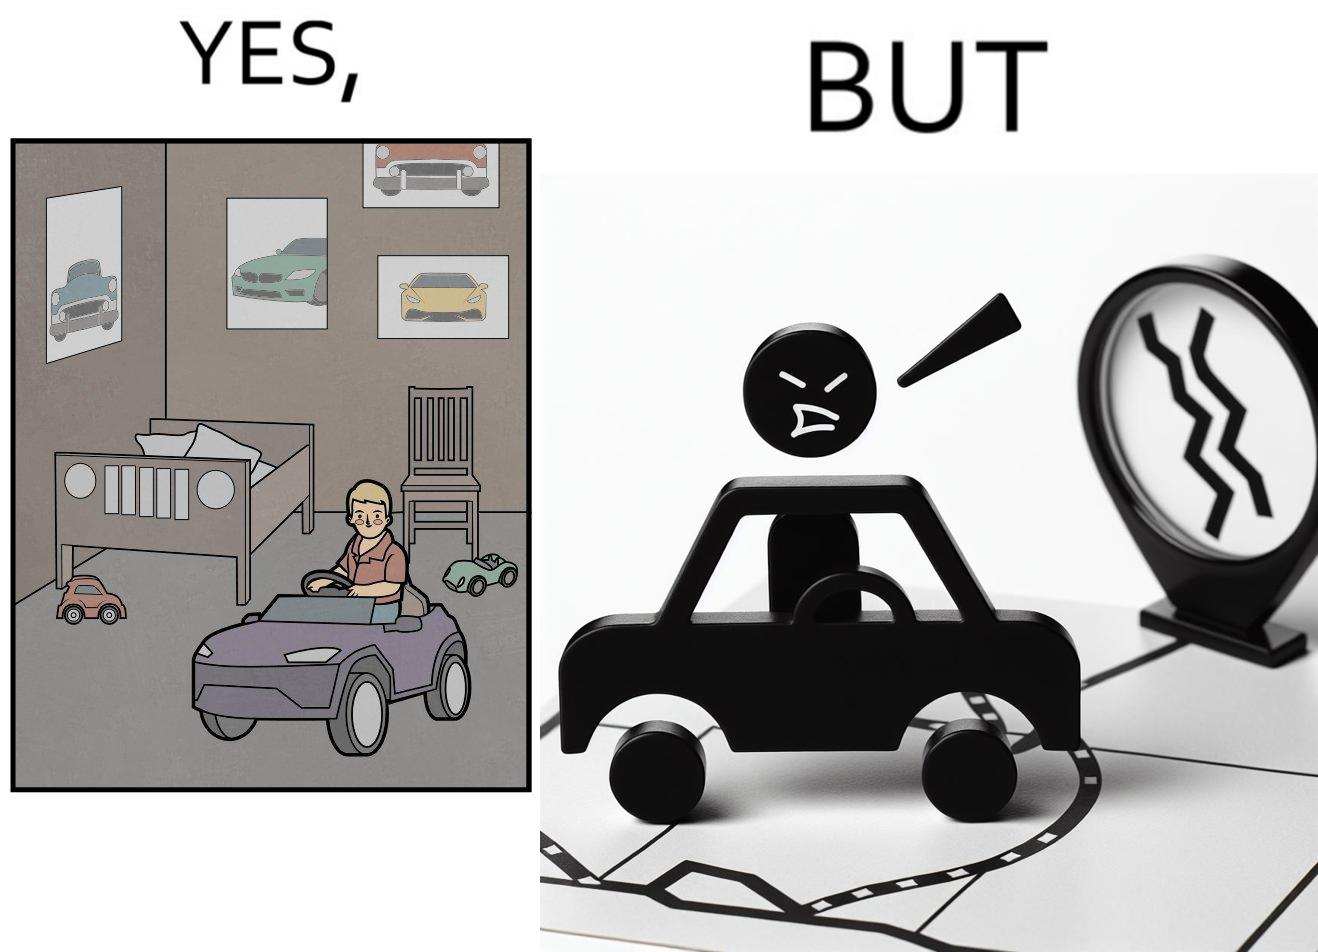What is shown in the left half versus the right half of this image? In the left part of the image: The image shows the bedroom of a child with various small toy cars and posters of cars on the wall. The child in the picture is also riding a bigger toy car. In the right part of the image: The image shows a man annoyed by the slow traffic on his way as shown on the map while he is driving. 